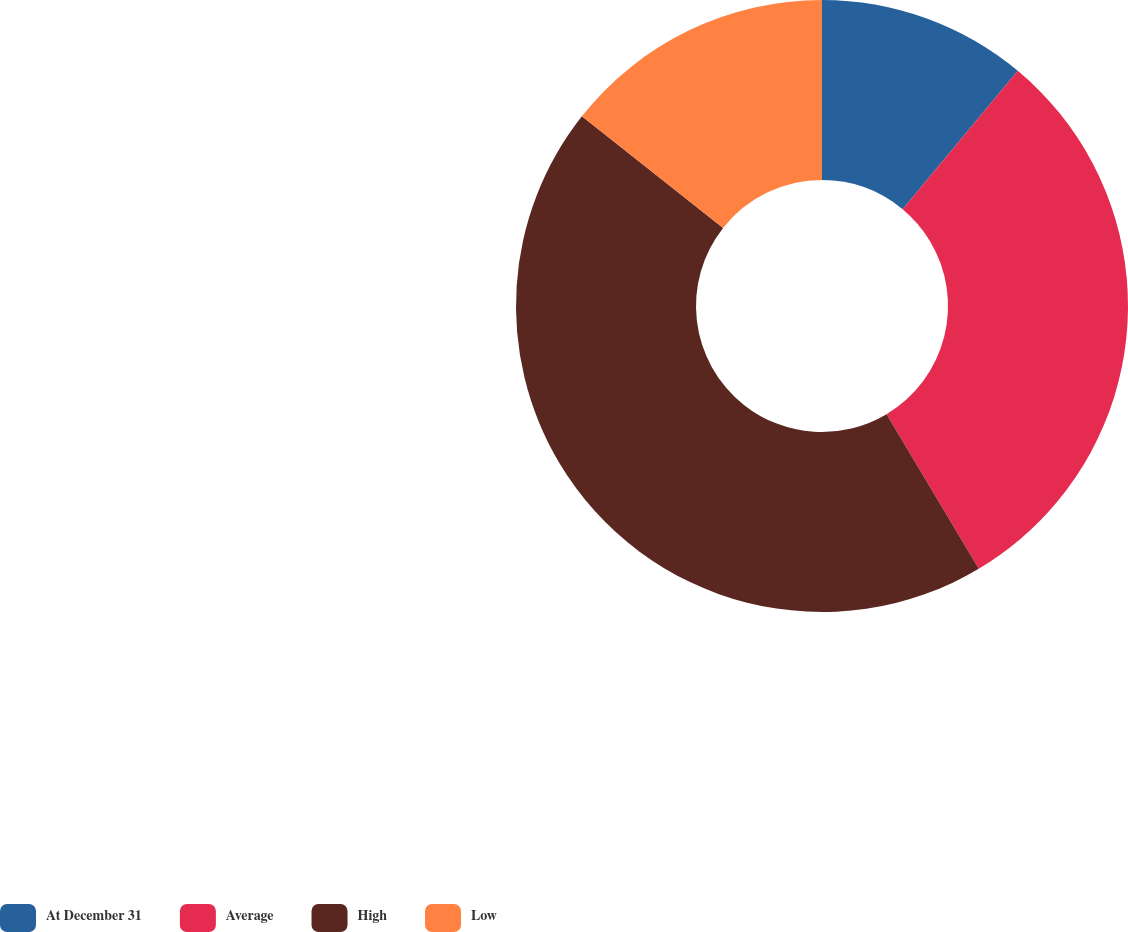Convert chart to OTSL. <chart><loc_0><loc_0><loc_500><loc_500><pie_chart><fcel>At December 31<fcel>Average<fcel>High<fcel>Low<nl><fcel>11.05%<fcel>30.39%<fcel>44.2%<fcel>14.36%<nl></chart> 